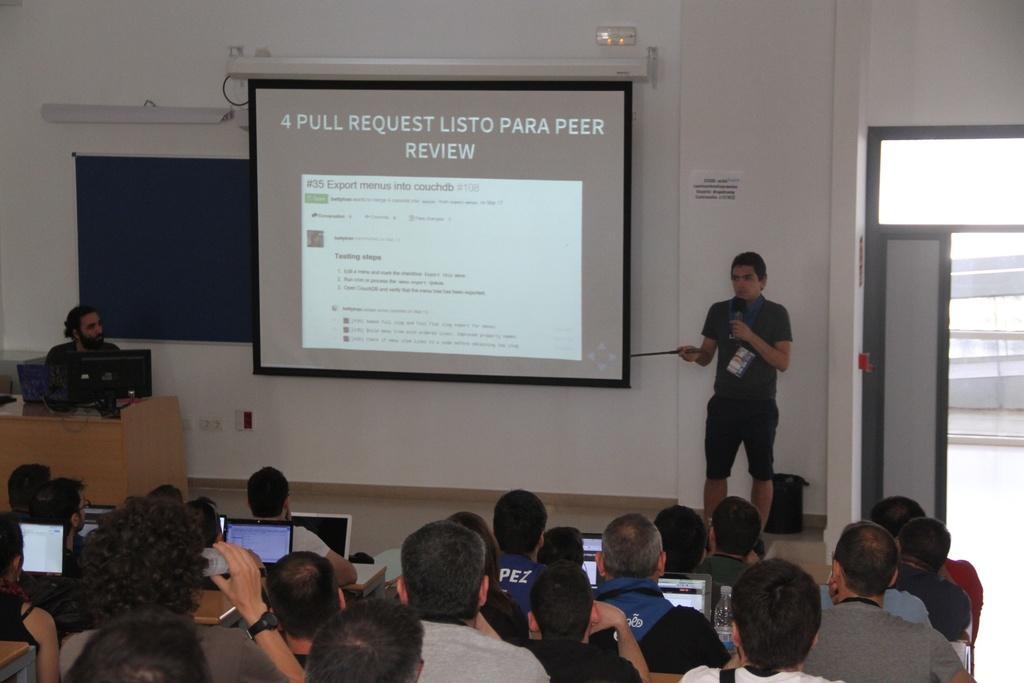In one or two sentences, can you explain what this image depicts? In this image we can see a person is standing, holding mic. Beside him one screen is there. In front of the person so many people are sitting and in front of the people laptops are present. To the left side of the image one table is there, on table monitor and laptop is there. Behind the table one person is sitting and board is present. The wall of the room is in white color. The door is in grey color. 